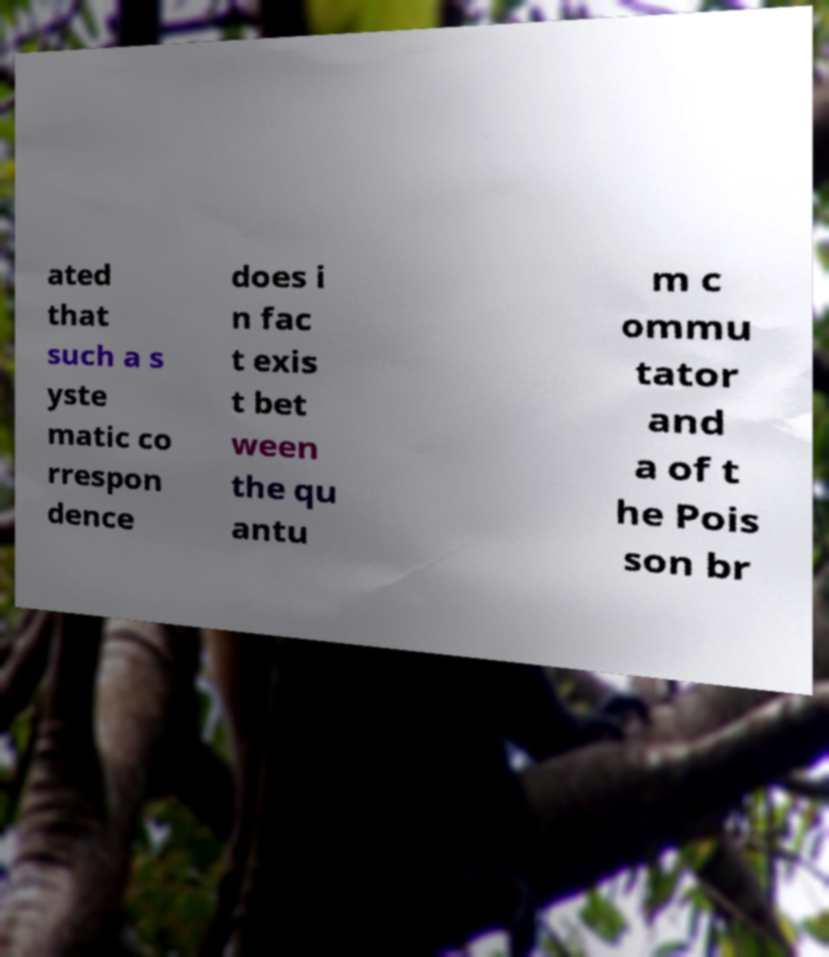Could you extract and type out the text from this image? ated that such a s yste matic co rrespon dence does i n fac t exis t bet ween the qu antu m c ommu tator and a of t he Pois son br 